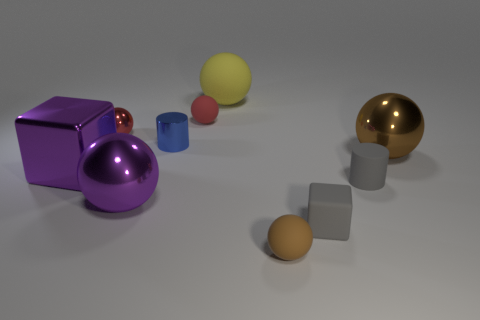Subtract all brown spheres. How many spheres are left? 4 Subtract all red balls. How many balls are left? 4 Subtract 1 balls. How many balls are left? 5 Subtract all blue balls. Subtract all red cubes. How many balls are left? 6 Subtract all balls. How many objects are left? 4 Add 8 tiny brown objects. How many tiny brown objects exist? 9 Subtract 1 gray blocks. How many objects are left? 9 Subtract all purple matte cylinders. Subtract all shiny objects. How many objects are left? 5 Add 6 small red metal things. How many small red metal things are left? 7 